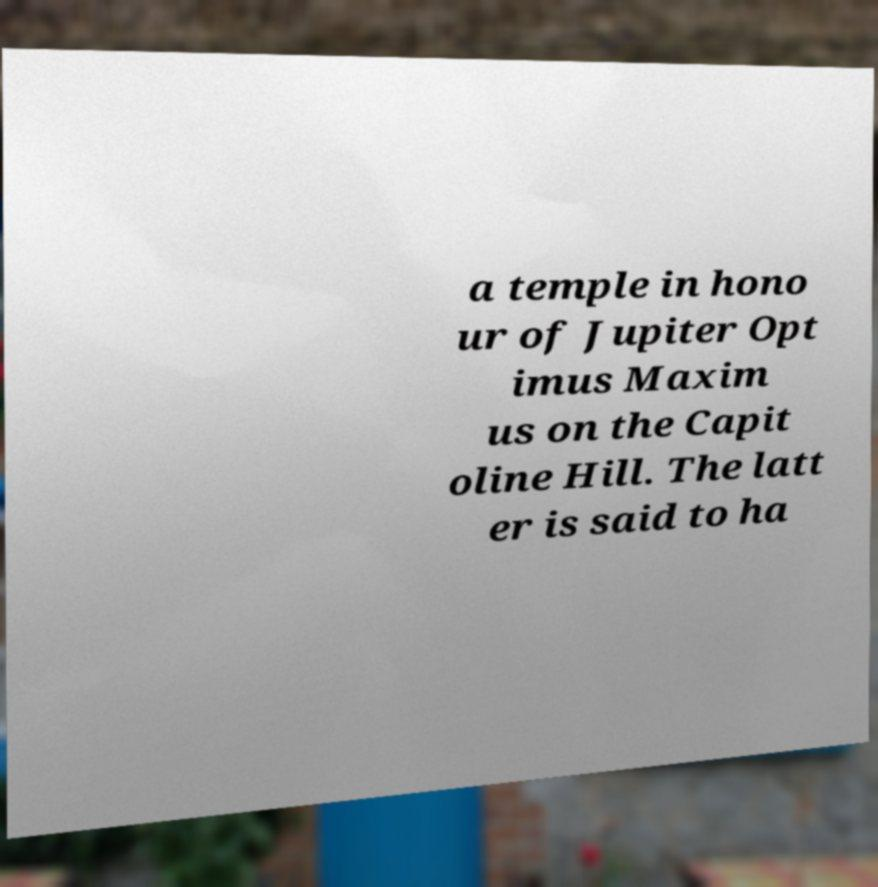Please read and relay the text visible in this image. What does it say? a temple in hono ur of Jupiter Opt imus Maxim us on the Capit oline Hill. The latt er is said to ha 